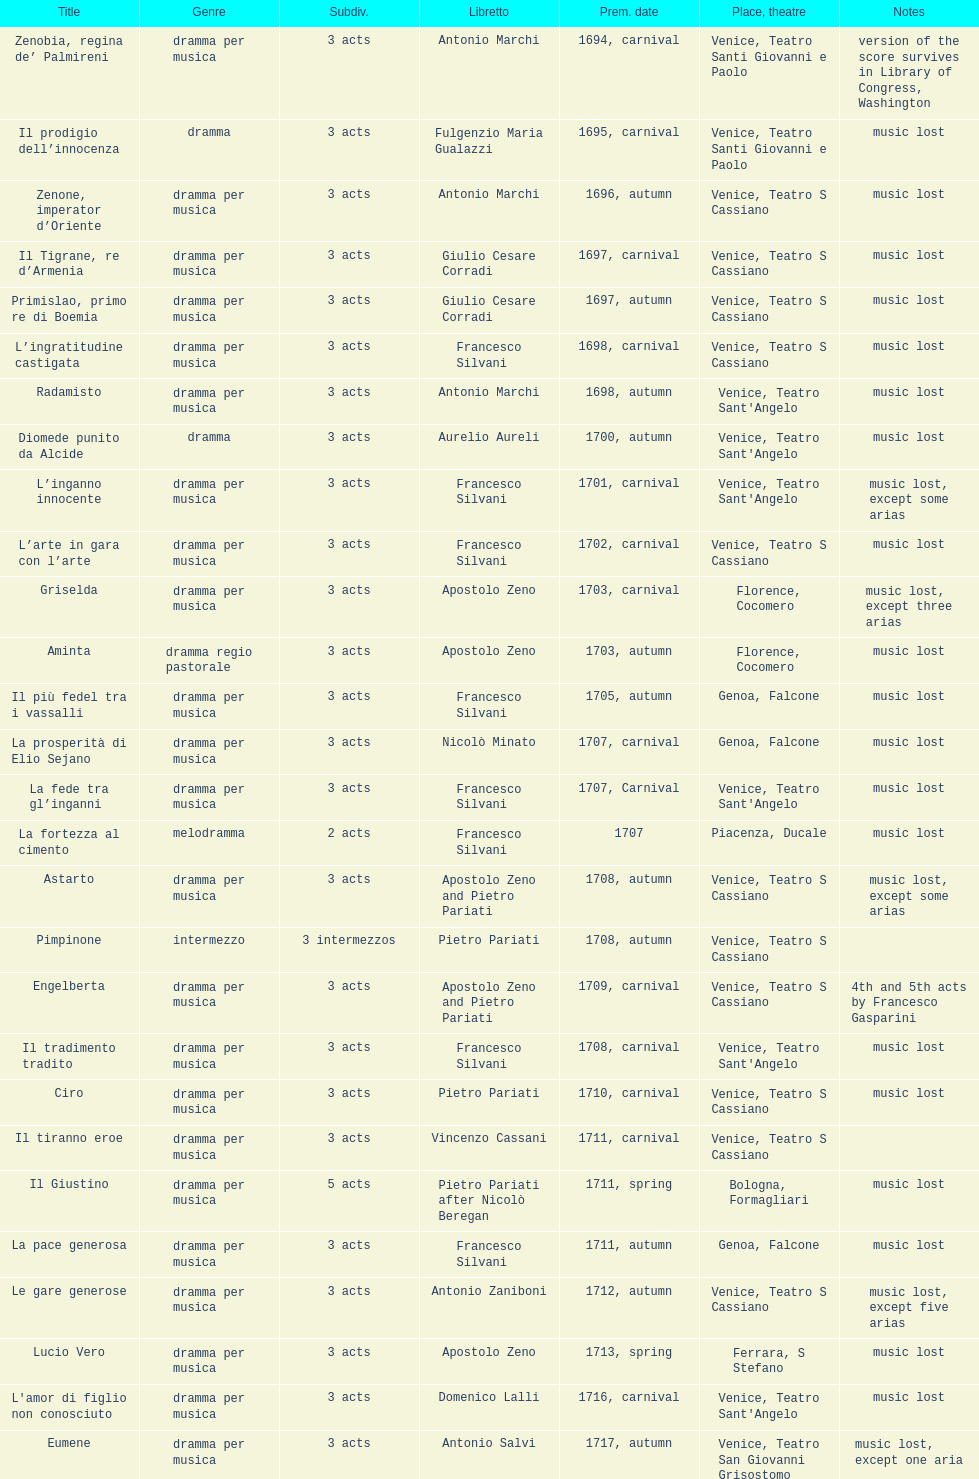Which was released earlier, artamene or merope? Merope. 